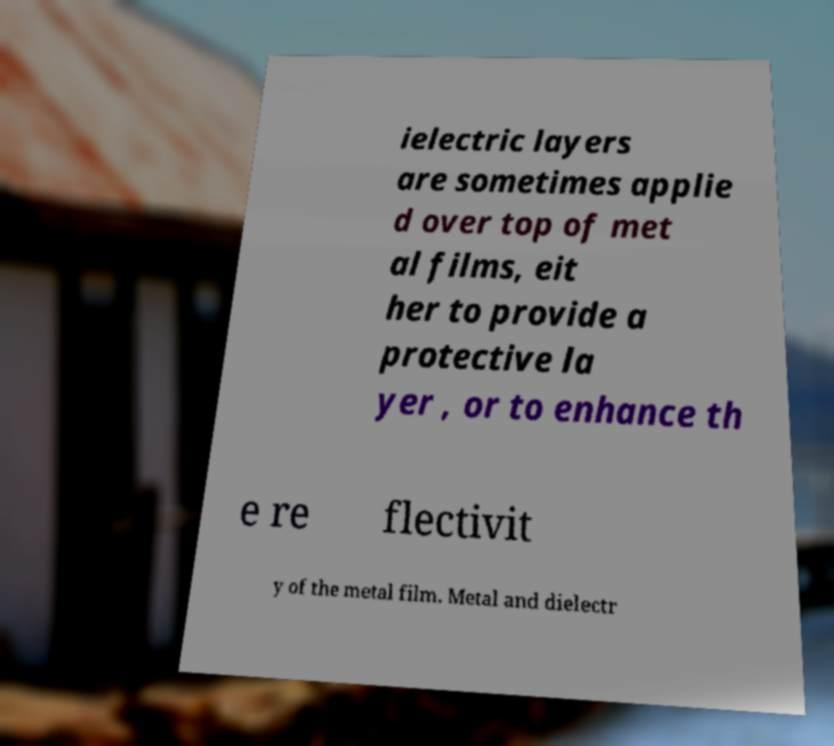Can you accurately transcribe the text from the provided image for me? ielectric layers are sometimes applie d over top of met al films, eit her to provide a protective la yer , or to enhance th e re flectivit y of the metal film. Metal and dielectr 